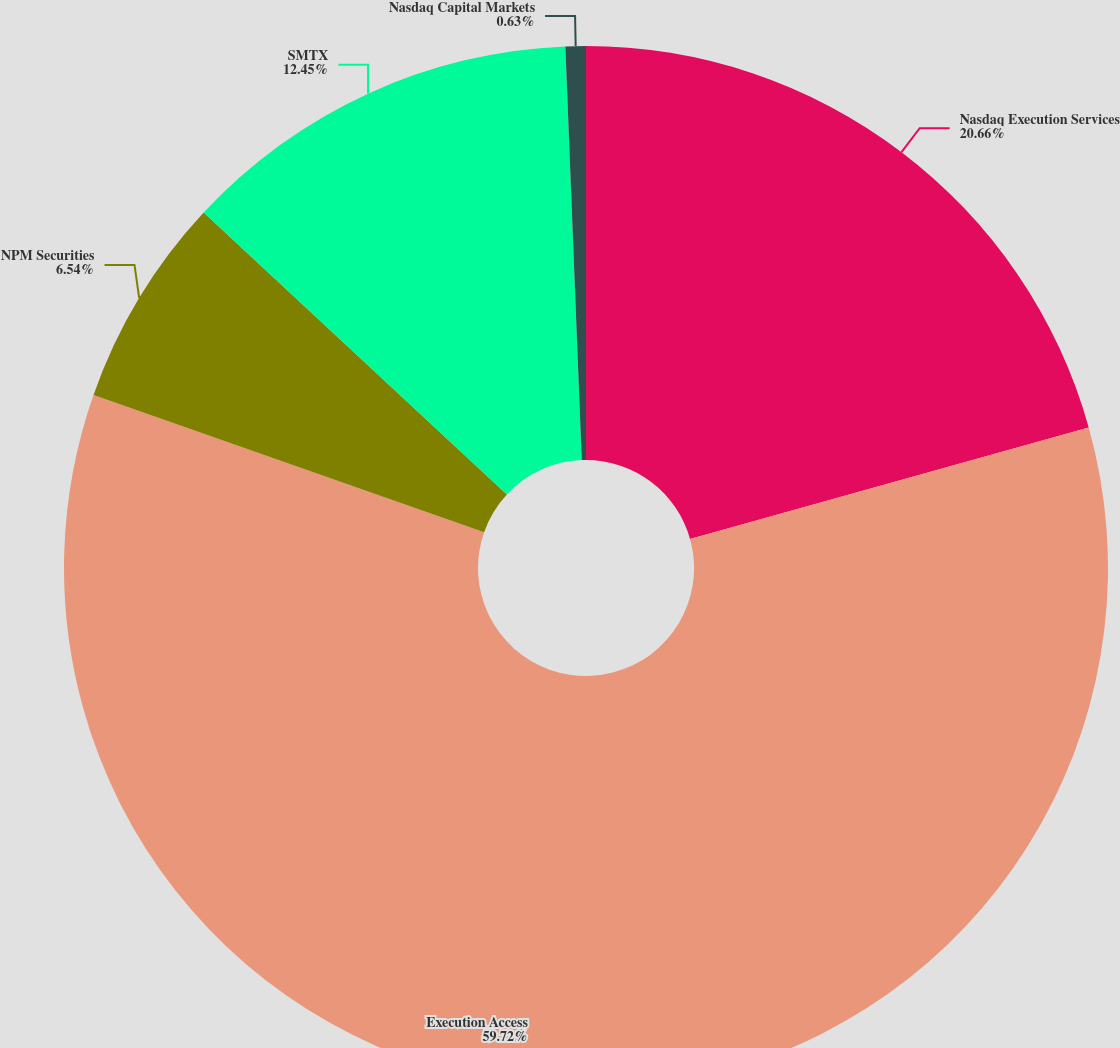Convert chart. <chart><loc_0><loc_0><loc_500><loc_500><pie_chart><fcel>Nasdaq Execution Services<fcel>Execution Access<fcel>NPM Securities<fcel>SMTX<fcel>Nasdaq Capital Markets<nl><fcel>20.66%<fcel>59.71%<fcel>6.54%<fcel>12.45%<fcel>0.63%<nl></chart> 